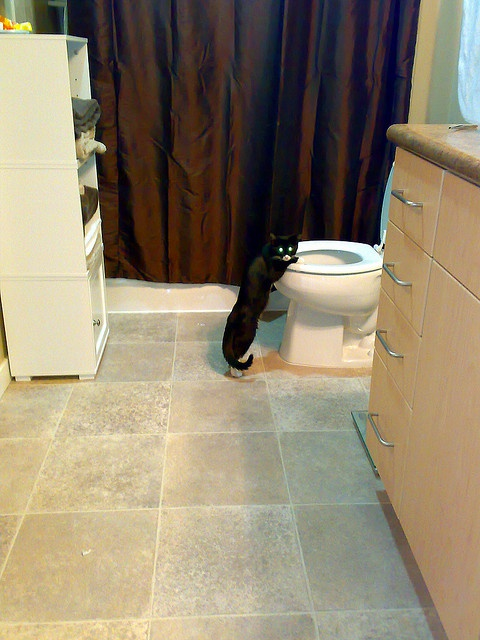Describe the objects in this image and their specific colors. I can see toilet in olive, tan, ivory, and darkgray tones and cat in olive, black, gray, ivory, and tan tones in this image. 